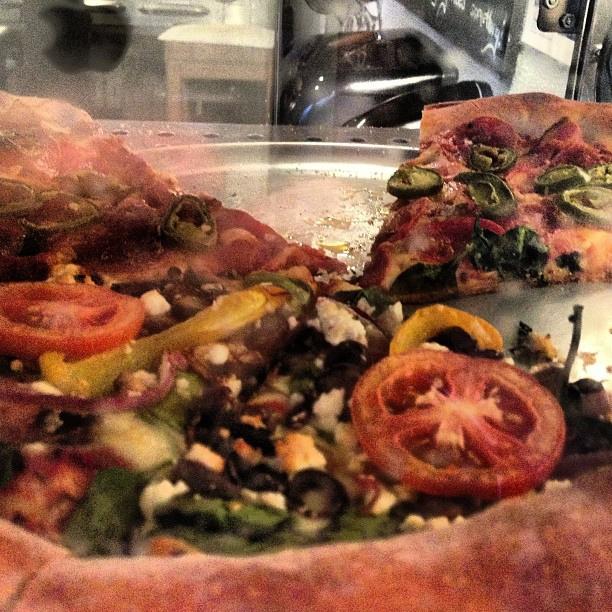Is that cooked?
Be succinct. Yes. What is the circular red on the pizza?
Keep it brief. Tomato. Is the pizza sliced?
Quick response, please. Yes. 